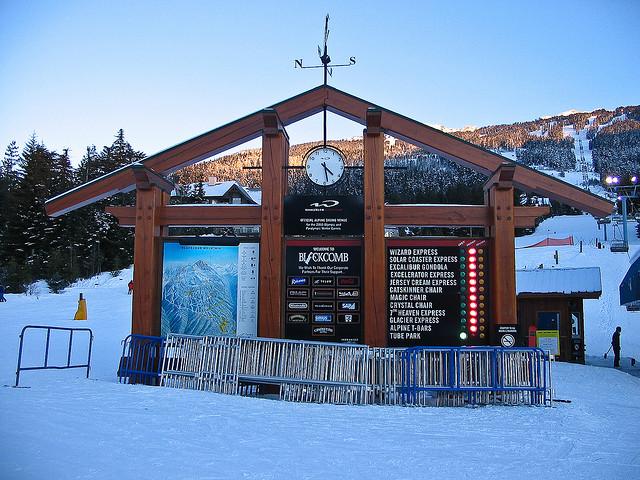Is this a ski resort?
Give a very brief answer. Yes. Is there a map on the building?
Quick response, please. Yes. What type of establishment is in the photo?
Be succinct. Ski resort. Where is this?
Short answer required. Mountains. What does the clock say?
Keep it brief. 4:28. 